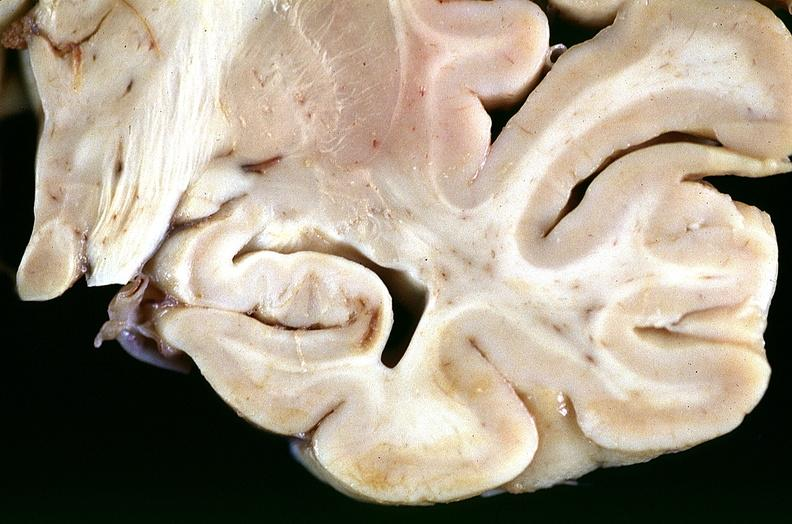what is present?
Answer the question using a single word or phrase. Nervous 